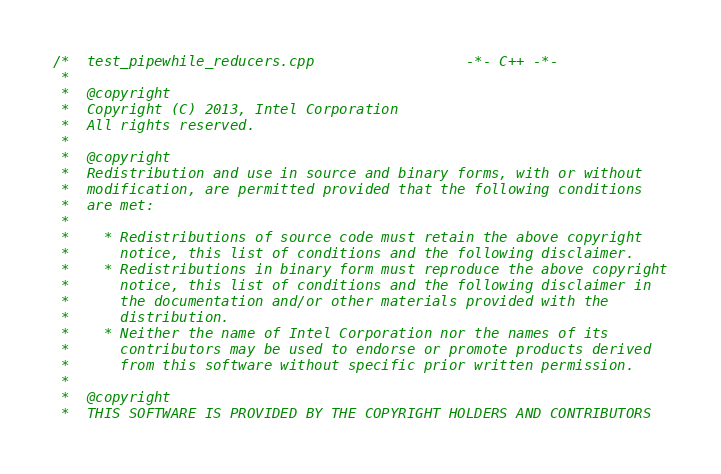<code> <loc_0><loc_0><loc_500><loc_500><_C++_>/*  test_pipewhile_reducers.cpp                  -*- C++ -*-
 *
 *  @copyright
 *  Copyright (C) 2013, Intel Corporation
 *  All rights reserved.
 *  
 *  @copyright
 *  Redistribution and use in source and binary forms, with or without
 *  modification, are permitted provided that the following conditions
 *  are met:
 *  
 *    * Redistributions of source code must retain the above copyright
 *      notice, this list of conditions and the following disclaimer.
 *    * Redistributions in binary form must reproduce the above copyright
 *      notice, this list of conditions and the following disclaimer in
 *      the documentation and/or other materials provided with the
 *      distribution.
 *    * Neither the name of Intel Corporation nor the names of its
 *      contributors may be used to endorse or promote products derived
 *      from this software without specific prior written permission.
 *  
 *  @copyright
 *  THIS SOFTWARE IS PROVIDED BY THE COPYRIGHT HOLDERS AND CONTRIBUTORS</code> 